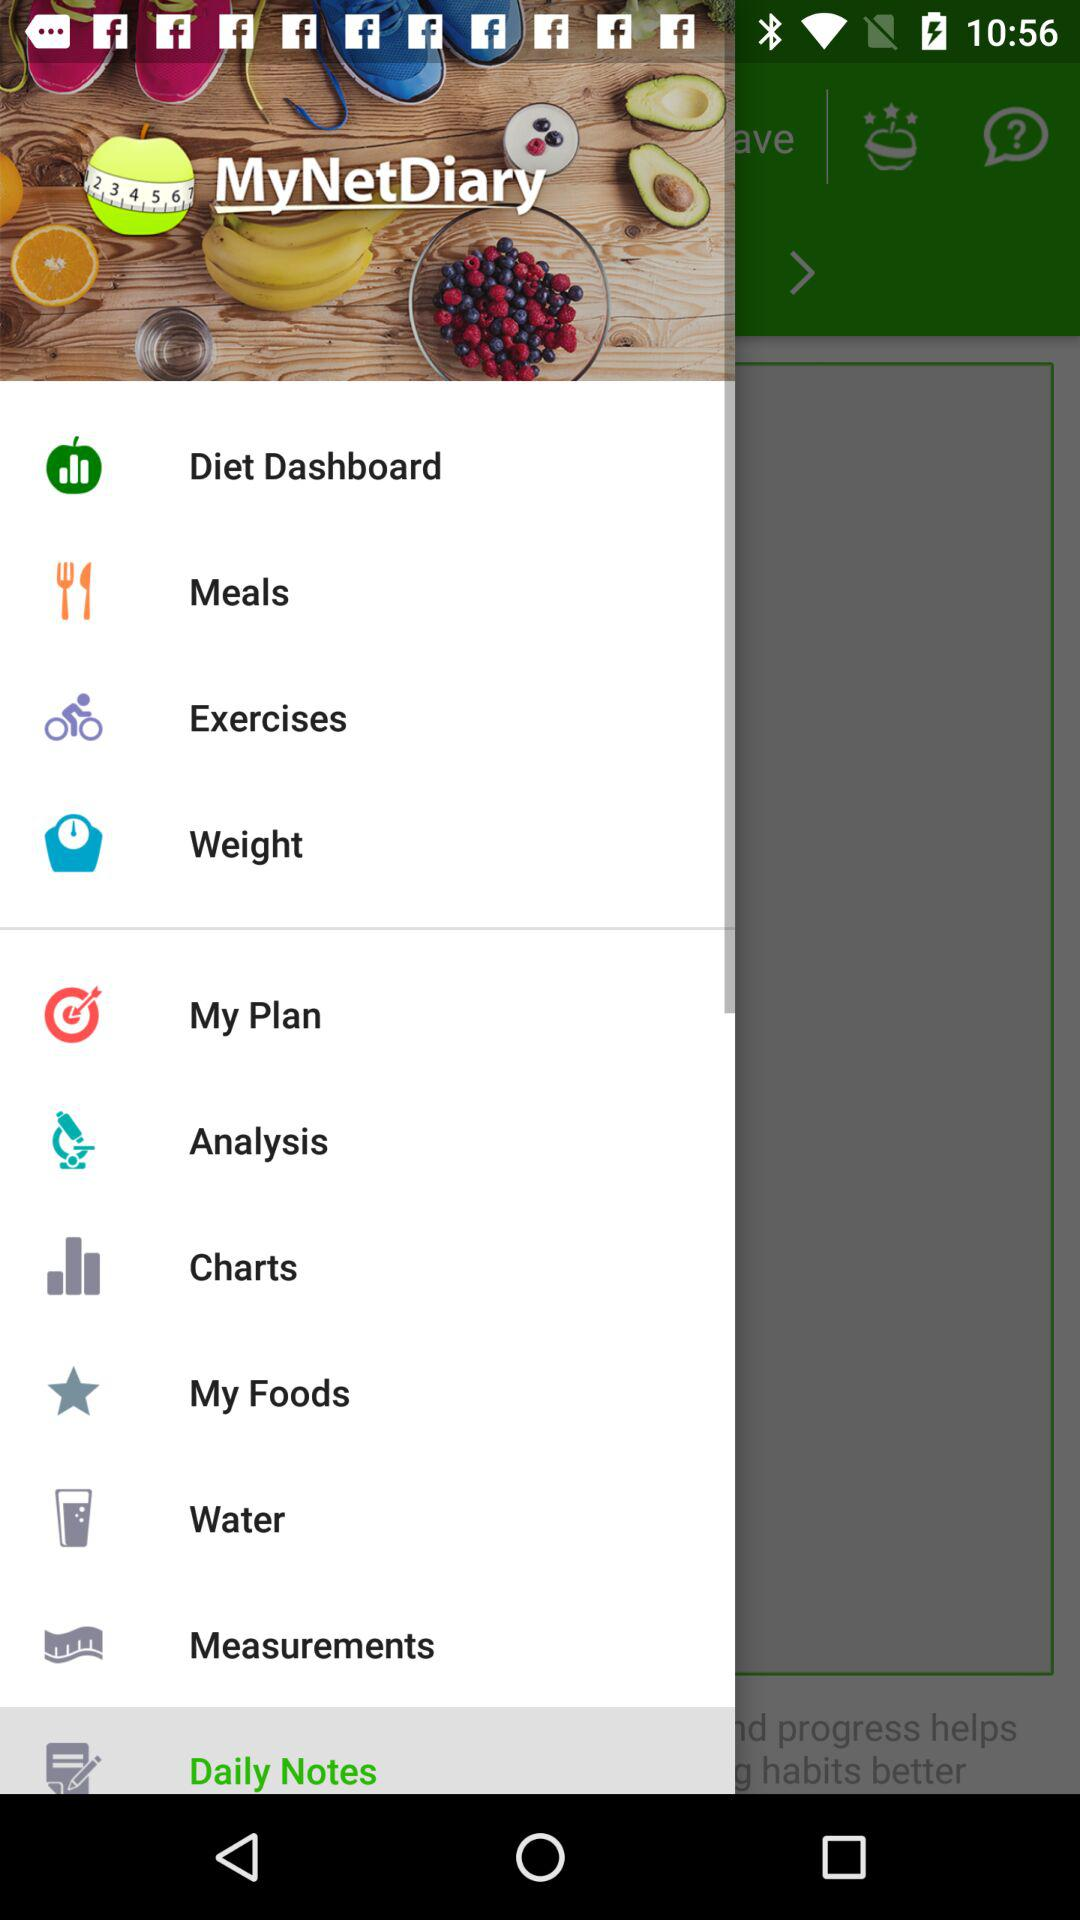What is the name of the application? The name of the application is "MyNetDiary". 